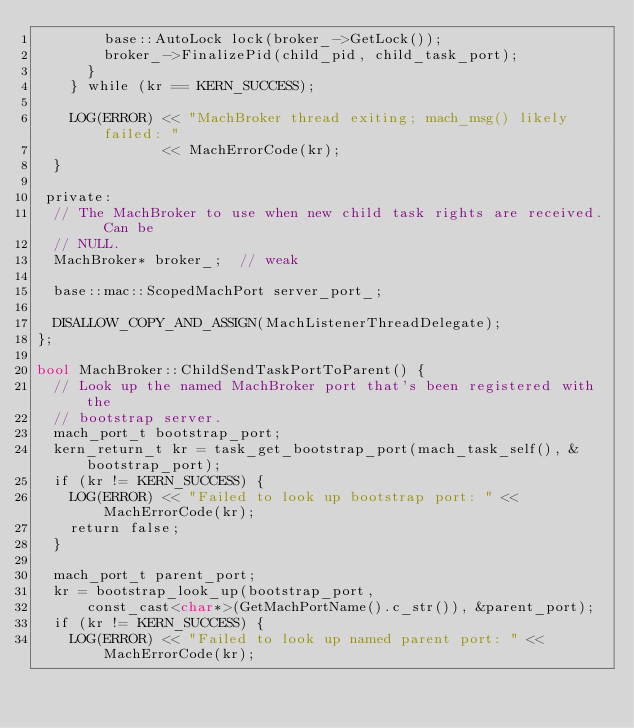<code> <loc_0><loc_0><loc_500><loc_500><_ObjectiveC_>        base::AutoLock lock(broker_->GetLock());
        broker_->FinalizePid(child_pid, child_task_port);
      }
    } while (kr == KERN_SUCCESS);

    LOG(ERROR) << "MachBroker thread exiting; mach_msg() likely failed: "
               << MachErrorCode(kr);
  }

 private:
  // The MachBroker to use when new child task rights are received.  Can be
  // NULL.
  MachBroker* broker_;  // weak

  base::mac::ScopedMachPort server_port_;

  DISALLOW_COPY_AND_ASSIGN(MachListenerThreadDelegate);
};

bool MachBroker::ChildSendTaskPortToParent() {
  // Look up the named MachBroker port that's been registered with the
  // bootstrap server.
  mach_port_t bootstrap_port;
  kern_return_t kr = task_get_bootstrap_port(mach_task_self(), &bootstrap_port);
  if (kr != KERN_SUCCESS) {
    LOG(ERROR) << "Failed to look up bootstrap port: " << MachErrorCode(kr);
    return false;
  }

  mach_port_t parent_port;
  kr = bootstrap_look_up(bootstrap_port,
      const_cast<char*>(GetMachPortName().c_str()), &parent_port);
  if (kr != KERN_SUCCESS) {
    LOG(ERROR) << "Failed to look up named parent port: " << MachErrorCode(kr);</code> 